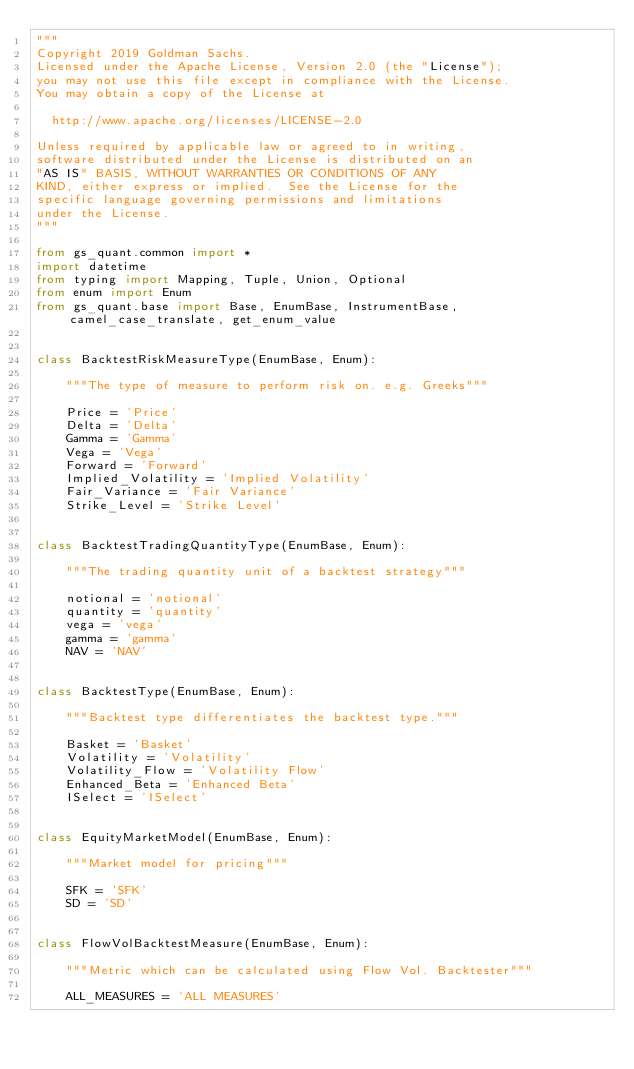Convert code to text. <code><loc_0><loc_0><loc_500><loc_500><_Python_>"""
Copyright 2019 Goldman Sachs.
Licensed under the Apache License, Version 2.0 (the "License");
you may not use this file except in compliance with the License.
You may obtain a copy of the License at

  http://www.apache.org/licenses/LICENSE-2.0

Unless required by applicable law or agreed to in writing,
software distributed under the License is distributed on an
"AS IS" BASIS, WITHOUT WARRANTIES OR CONDITIONS OF ANY
KIND, either express or implied.  See the License for the
specific language governing permissions and limitations
under the License.
"""

from gs_quant.common import *
import datetime
from typing import Mapping, Tuple, Union, Optional
from enum import Enum
from gs_quant.base import Base, EnumBase, InstrumentBase, camel_case_translate, get_enum_value


class BacktestRiskMeasureType(EnumBase, Enum):    
    
    """The type of measure to perform risk on. e.g. Greeks"""

    Price = 'Price'
    Delta = 'Delta'
    Gamma = 'Gamma'
    Vega = 'Vega'
    Forward = 'Forward'
    Implied_Volatility = 'Implied Volatility'
    Fair_Variance = 'Fair Variance'
    Strike_Level = 'Strike Level'    


class BacktestTradingQuantityType(EnumBase, Enum):    
    
    """The trading quantity unit of a backtest strategy"""

    notional = 'notional'
    quantity = 'quantity'
    vega = 'vega'
    gamma = 'gamma'
    NAV = 'NAV'    


class BacktestType(EnumBase, Enum):    
    
    """Backtest type differentiates the backtest type."""

    Basket = 'Basket'
    Volatility = 'Volatility'
    Volatility_Flow = 'Volatility Flow'
    Enhanced_Beta = 'Enhanced Beta'
    ISelect = 'ISelect'    


class EquityMarketModel(EnumBase, Enum):    
    
    """Market model for pricing"""

    SFK = 'SFK'
    SD = 'SD'    


class FlowVolBacktestMeasure(EnumBase, Enum):    
    
    """Metric which can be calculated using Flow Vol. Backtester"""

    ALL_MEASURES = 'ALL MEASURES'</code> 